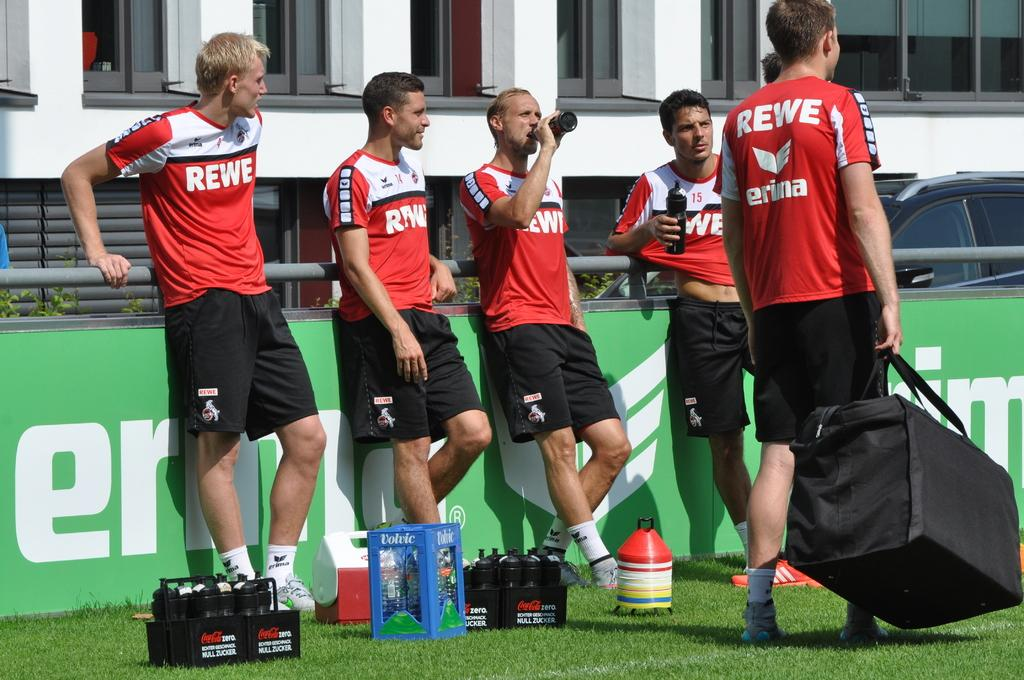<image>
Relay a brief, clear account of the picture shown. Soccer players on a field with REWE on their shirts. 